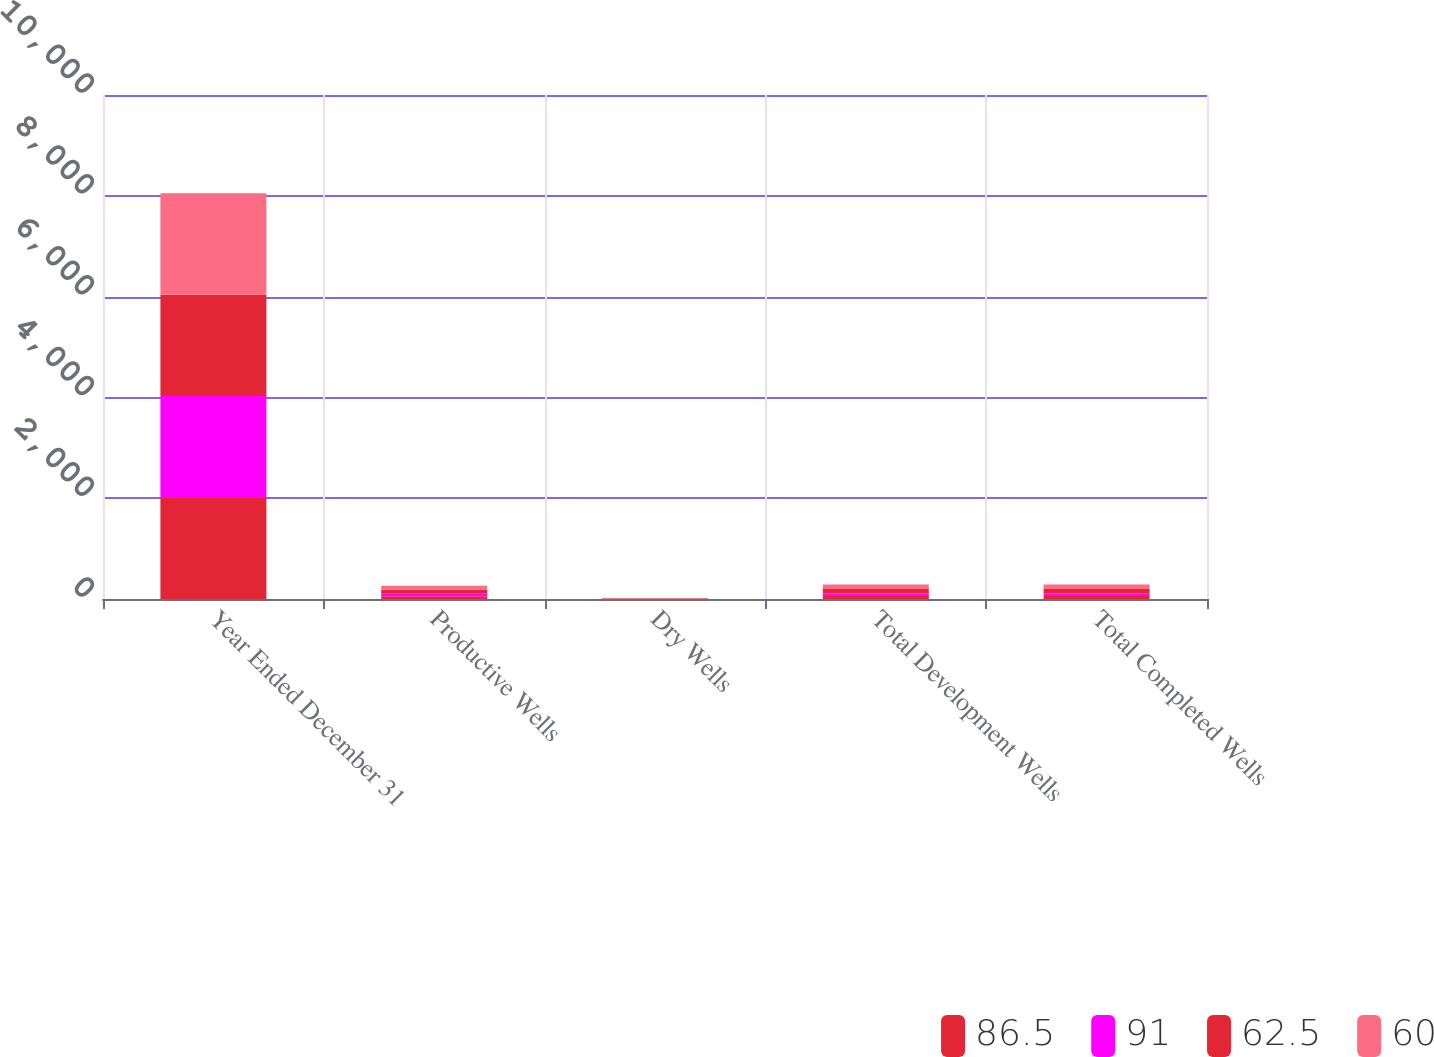<chart> <loc_0><loc_0><loc_500><loc_500><stacked_bar_chart><ecel><fcel>Year Ended December 31<fcel>Productive Wells<fcel>Dry Wells<fcel>Total Development Wells<fcel>Total Completed Wells<nl><fcel>86.5<fcel>2013<fcel>57<fcel>3<fcel>60<fcel>60<nl><fcel>91<fcel>2013<fcel>45.3<fcel>3<fcel>48.3<fcel>48.3<nl><fcel>62.5<fcel>2012<fcel>83<fcel>8<fcel>91<fcel>91<nl><fcel>60<fcel>2012<fcel>78.5<fcel>8<fcel>86.5<fcel>86.5<nl></chart> 